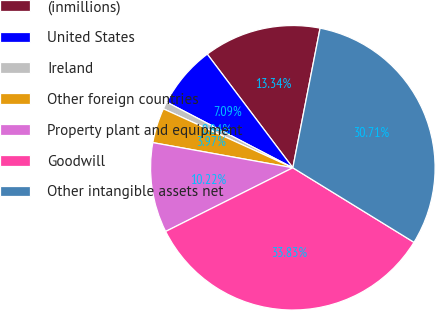Convert chart to OTSL. <chart><loc_0><loc_0><loc_500><loc_500><pie_chart><fcel>(inmillions)<fcel>United States<fcel>Ireland<fcel>Other foreign countries<fcel>Property plant and equipment<fcel>Goodwill<fcel>Other intangible assets net<nl><fcel>13.34%<fcel>7.09%<fcel>0.84%<fcel>3.97%<fcel>10.22%<fcel>33.83%<fcel>30.71%<nl></chart> 